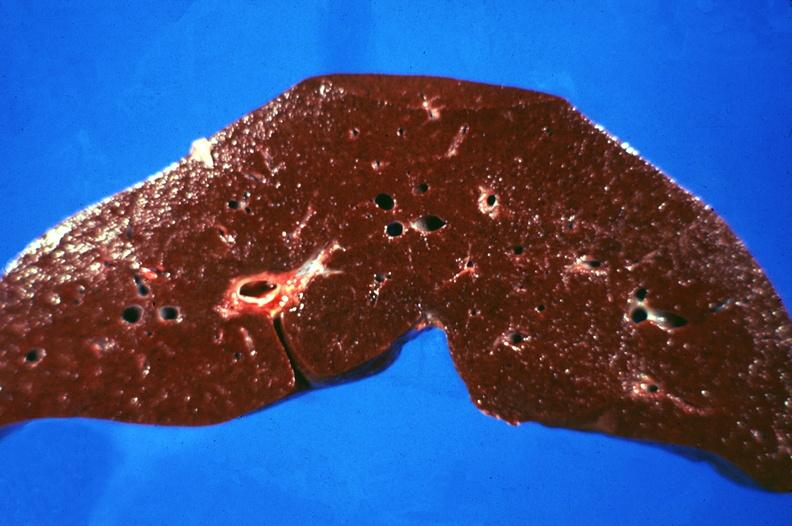s hepatobiliary present?
Answer the question using a single word or phrase. Yes 